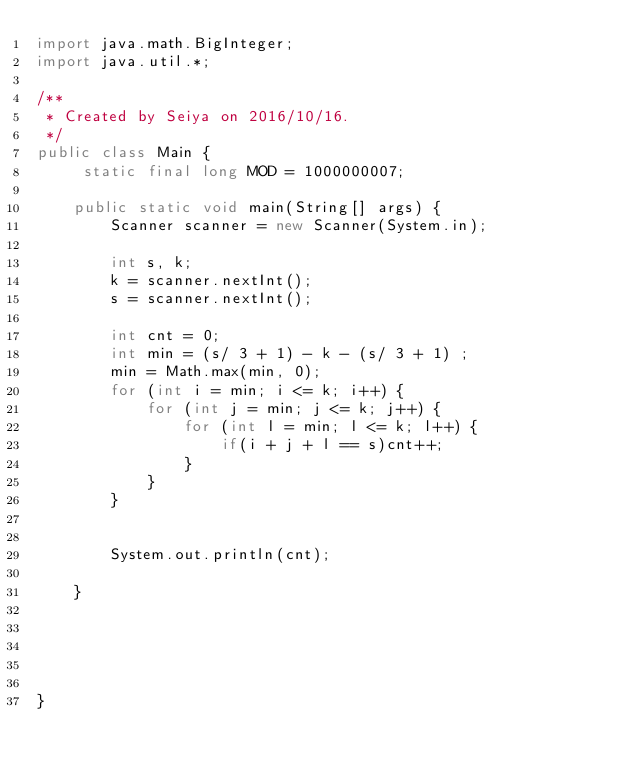<code> <loc_0><loc_0><loc_500><loc_500><_Java_>import java.math.BigInteger;
import java.util.*;

/**
 * Created by Seiya on 2016/10/16.
 */
public class Main {
     static final long MOD = 1000000007;

    public static void main(String[] args) {
        Scanner scanner = new Scanner(System.in);

        int s, k;
        k = scanner.nextInt();
        s = scanner.nextInt();

        int cnt = 0;
        int min = (s/ 3 + 1) - k - (s/ 3 + 1) ;
        min = Math.max(min, 0);
        for (int i = min; i <= k; i++) {
            for (int j = min; j <= k; j++) {
                for (int l = min; l <= k; l++) {
                    if(i + j + l == s)cnt++;
                }
            }
        }


        System.out.println(cnt);

    }





}


</code> 